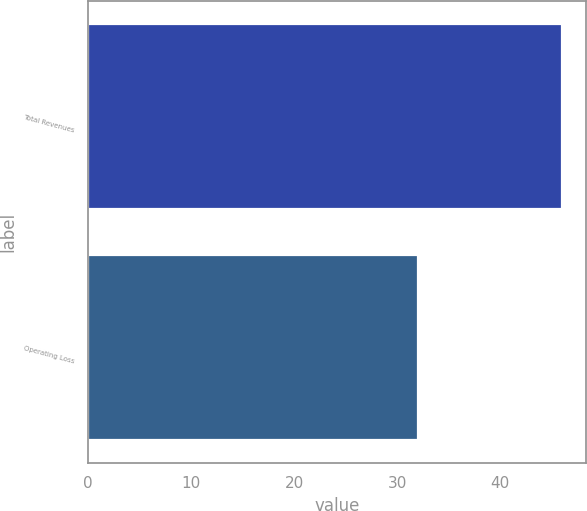Convert chart. <chart><loc_0><loc_0><loc_500><loc_500><bar_chart><fcel>Total Revenues<fcel>Operating Loss<nl><fcel>46<fcel>32<nl></chart> 